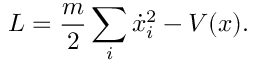<formula> <loc_0><loc_0><loc_500><loc_500>L = { \frac { m } { 2 } } \sum _ { i } { \dot { x } } _ { i } ^ { 2 } - V ( x ) .</formula> 